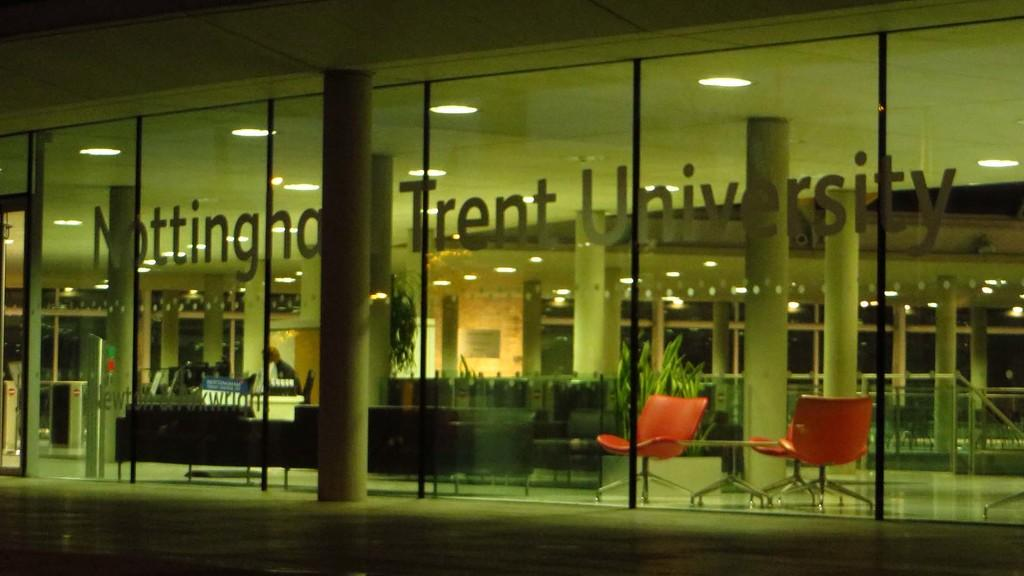What type of building is depicted in the image? The building has a glass wall and pillars. What can be seen on the glass wall? Something is written on the glass wall. What type of furniture is inside the building? There are sofas and chairs inside the building. What else can be found inside the building? There are plants inside the building. What is present on the ceiling of the building? There are lights on the ceiling of the building. What type of music can be heard coming from the cakes in the image? There are no cakes present in the image, and therefore no music can be heard from them. 